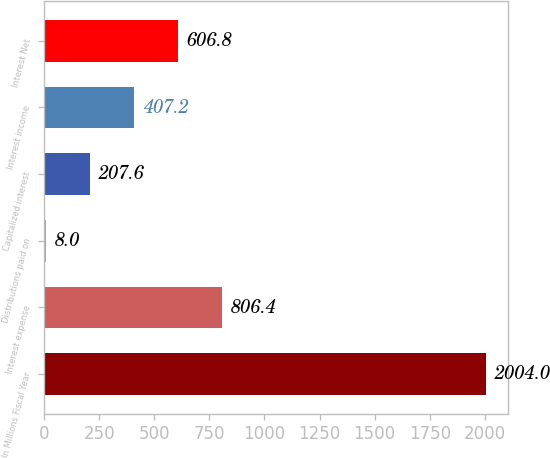Convert chart to OTSL. <chart><loc_0><loc_0><loc_500><loc_500><bar_chart><fcel>In Millions Fiscal Year<fcel>Interest expense<fcel>Distributions paid on<fcel>Capitalized interest<fcel>Interest income<fcel>Interest Net<nl><fcel>2004<fcel>806.4<fcel>8<fcel>207.6<fcel>407.2<fcel>606.8<nl></chart> 